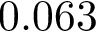<formula> <loc_0><loc_0><loc_500><loc_500>0 . 0 6 3</formula> 